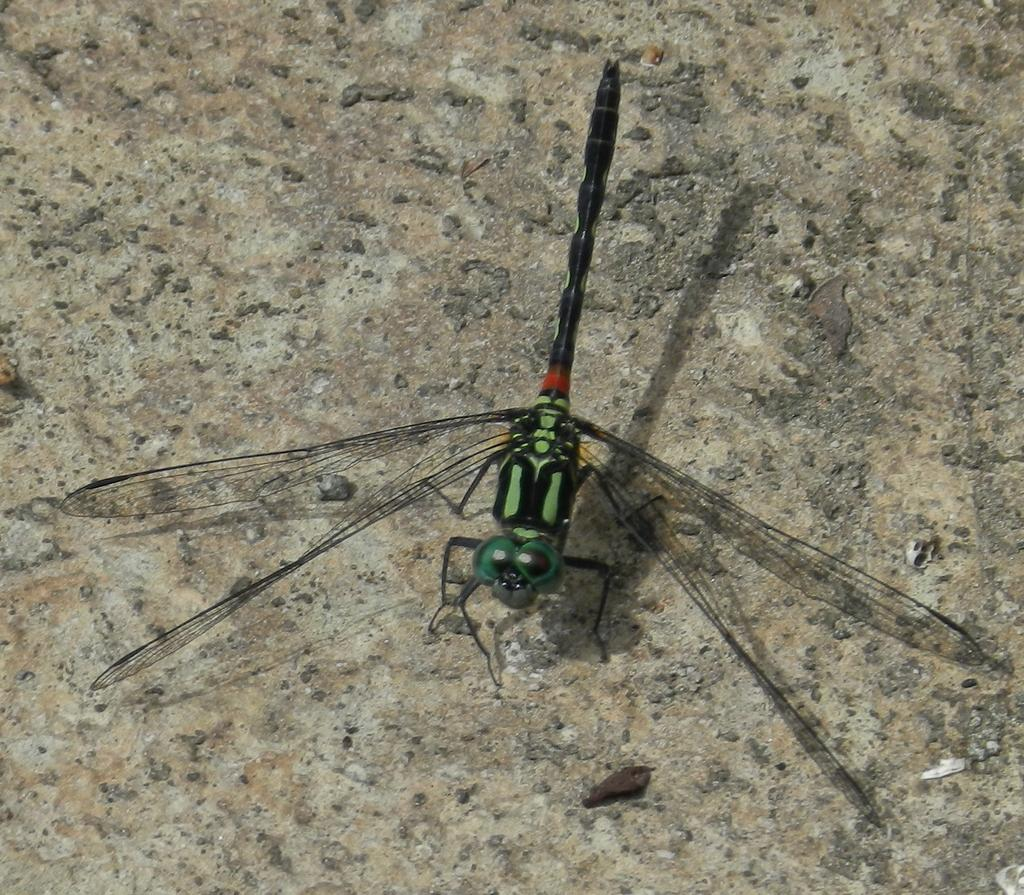What type of creature is present in the image? There is an insect in the image. Where is the insect located in the image? The insect is on a surface. What substance are the girls using to create their art in the image? There are no girls or art present in the image; it only features an insect on a surface. 